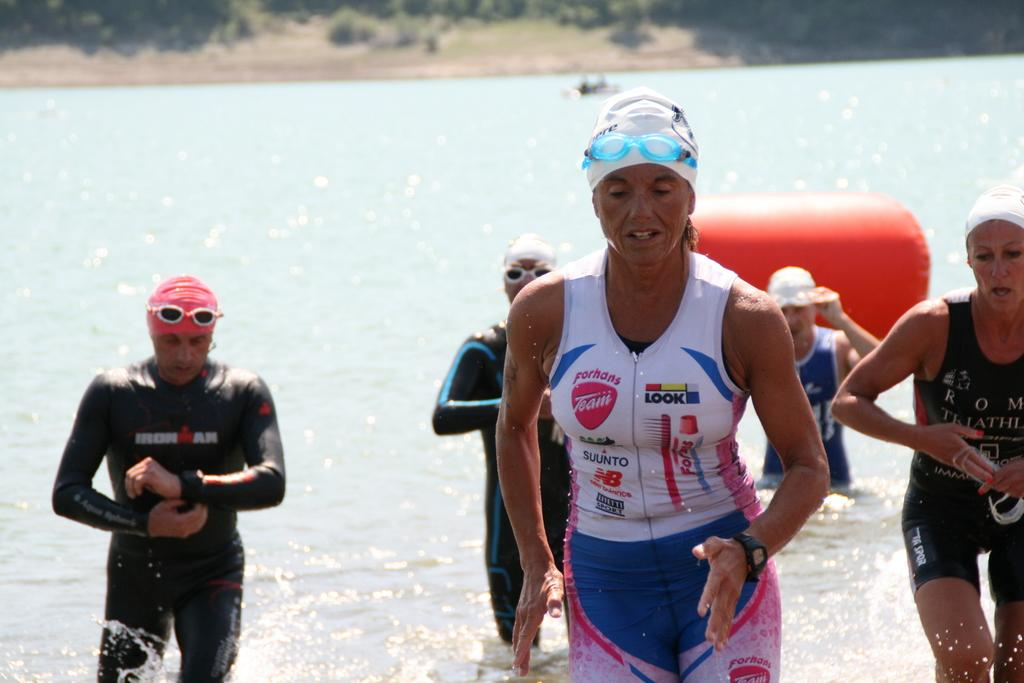What are the people in the image doing? The people in the image are in the water. What can be seen in the background of the image? There are plants and trees in the background of the image. What type of drink is being served in the image? There is no drink present in the image; it features people in the water and plants and trees in the background. 